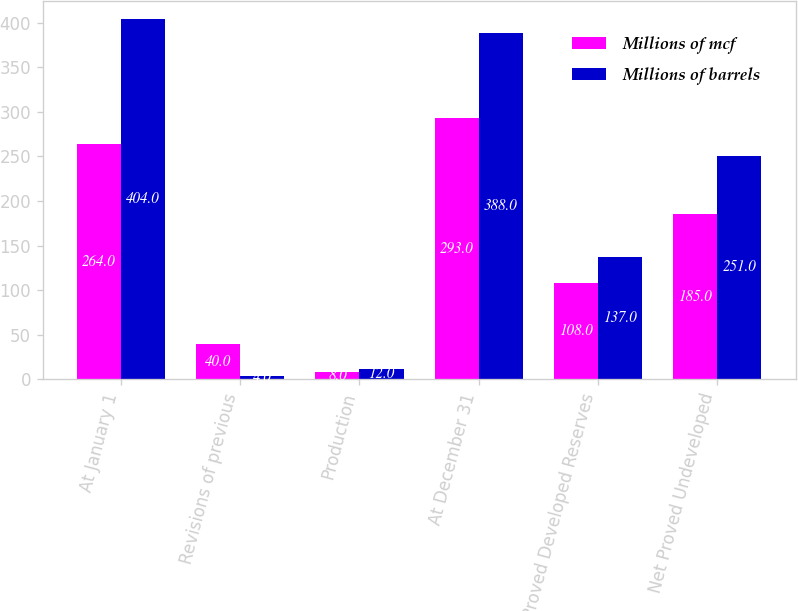Convert chart to OTSL. <chart><loc_0><loc_0><loc_500><loc_500><stacked_bar_chart><ecel><fcel>At January 1<fcel>Revisions of previous<fcel>Production<fcel>At December 31<fcel>Net Proved Developed Reserves<fcel>Net Proved Undeveloped<nl><fcel>Millions of mcf<fcel>264<fcel>40<fcel>8<fcel>293<fcel>108<fcel>185<nl><fcel>Millions of barrels<fcel>404<fcel>4<fcel>12<fcel>388<fcel>137<fcel>251<nl></chart> 